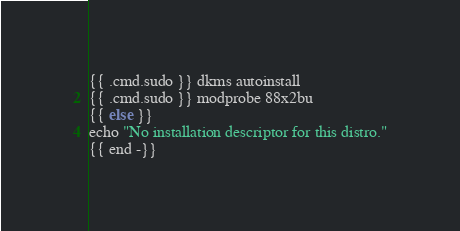<code> <loc_0><loc_0><loc_500><loc_500><_Bash_>{{ .cmd.sudo }} dkms autoinstall
{{ .cmd.sudo }} modprobe 88x2bu
{{ else }}
echo "No installation descriptor for this distro."
{{ end -}}
</code> 